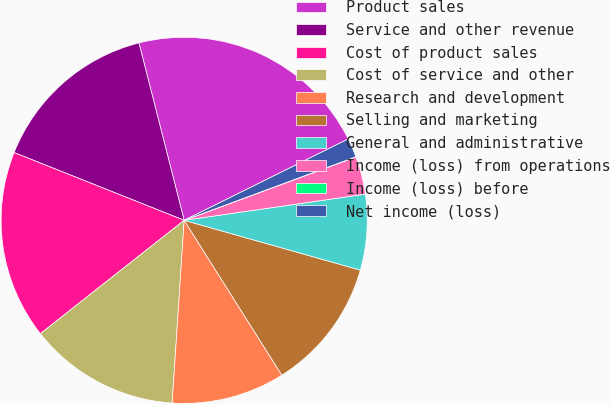<chart> <loc_0><loc_0><loc_500><loc_500><pie_chart><fcel>Product sales<fcel>Service and other revenue<fcel>Cost of product sales<fcel>Cost of service and other<fcel>Research and development<fcel>Selling and marketing<fcel>General and administrative<fcel>Income (loss) from operations<fcel>Income (loss) before<fcel>Net income (loss)<nl><fcel>21.65%<fcel>14.99%<fcel>16.66%<fcel>13.33%<fcel>10.0%<fcel>11.66%<fcel>6.67%<fcel>3.34%<fcel>0.02%<fcel>1.68%<nl></chart> 